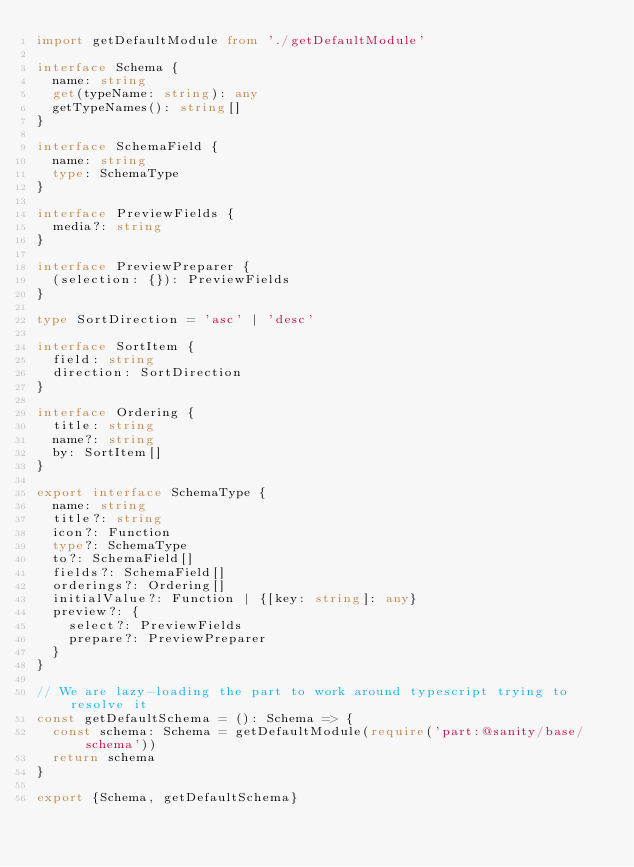<code> <loc_0><loc_0><loc_500><loc_500><_TypeScript_>import getDefaultModule from './getDefaultModule'

interface Schema {
  name: string
  get(typeName: string): any
  getTypeNames(): string[]
}

interface SchemaField {
  name: string
  type: SchemaType
}

interface PreviewFields {
  media?: string
}

interface PreviewPreparer {
  (selection: {}): PreviewFields
}

type SortDirection = 'asc' | 'desc'

interface SortItem {
  field: string
  direction: SortDirection
}

interface Ordering {
  title: string
  name?: string
  by: SortItem[]
}

export interface SchemaType {
  name: string
  title?: string
  icon?: Function
  type?: SchemaType
  to?: SchemaField[]
  fields?: SchemaField[]
  orderings?: Ordering[]
  initialValue?: Function | {[key: string]: any}
  preview?: {
    select?: PreviewFields
    prepare?: PreviewPreparer
  }
}

// We are lazy-loading the part to work around typescript trying to resolve it
const getDefaultSchema = (): Schema => {
  const schema: Schema = getDefaultModule(require('part:@sanity/base/schema'))
  return schema
}

export {Schema, getDefaultSchema}
</code> 